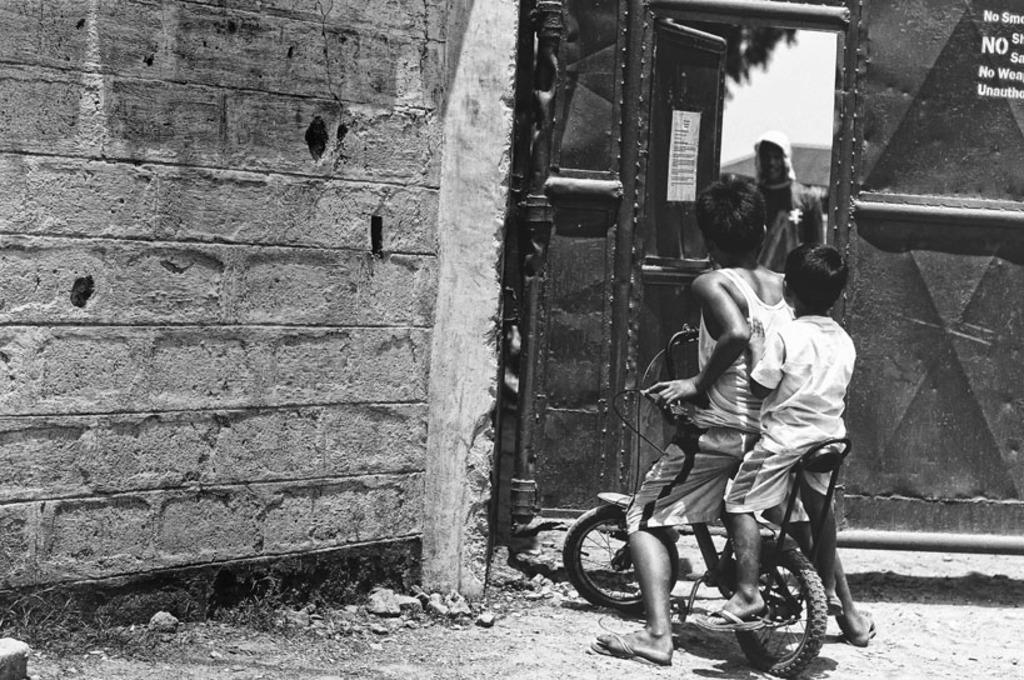What is the color scheme of the image? The image is black and white. What are the kids doing in the image? The two kids are sitting on a bicycle. Can you describe any architectural features in the image? There is a door in the image. What is happening behind the door? A person is standing behind the door. Is there any additional decoration or information on the door? Yes, there is a poster on the door. What type of shock can be seen affecting the kids on the bicycle in the image? There is no shock present in the image; the kids are simply sitting on the bicycle. What type of play or fight is happening between the kids and the person behind the door? There is no play or fight depicted in the image; the kids are sitting on the bicycle, and a person is standing behind the door. 